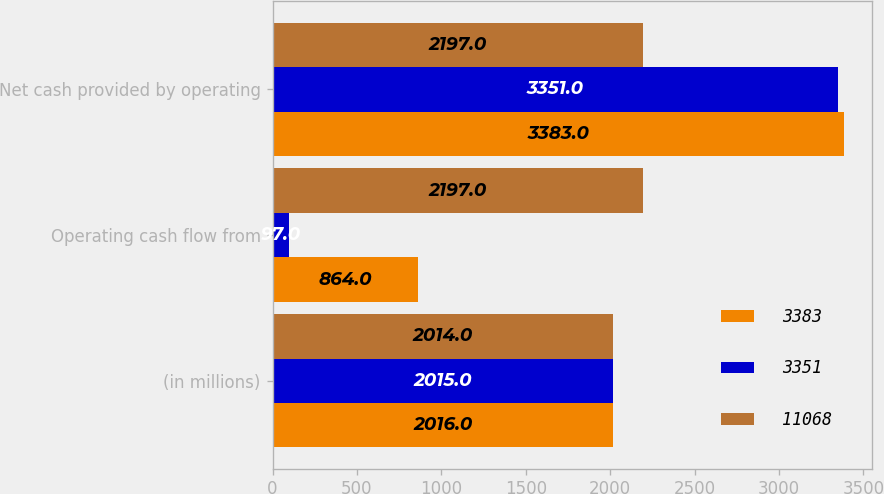Convert chart. <chart><loc_0><loc_0><loc_500><loc_500><stacked_bar_chart><ecel><fcel>(in millions)<fcel>Operating cash flow from<fcel>Net cash provided by operating<nl><fcel>3383<fcel>2016<fcel>864<fcel>3383<nl><fcel>3351<fcel>2015<fcel>97<fcel>3351<nl><fcel>11068<fcel>2014<fcel>2197<fcel>2197<nl></chart> 